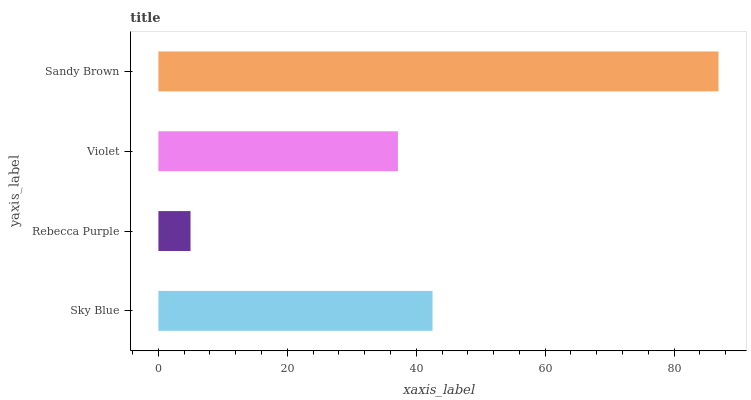Is Rebecca Purple the minimum?
Answer yes or no. Yes. Is Sandy Brown the maximum?
Answer yes or no. Yes. Is Violet the minimum?
Answer yes or no. No. Is Violet the maximum?
Answer yes or no. No. Is Violet greater than Rebecca Purple?
Answer yes or no. Yes. Is Rebecca Purple less than Violet?
Answer yes or no. Yes. Is Rebecca Purple greater than Violet?
Answer yes or no. No. Is Violet less than Rebecca Purple?
Answer yes or no. No. Is Sky Blue the high median?
Answer yes or no. Yes. Is Violet the low median?
Answer yes or no. Yes. Is Violet the high median?
Answer yes or no. No. Is Sky Blue the low median?
Answer yes or no. No. 